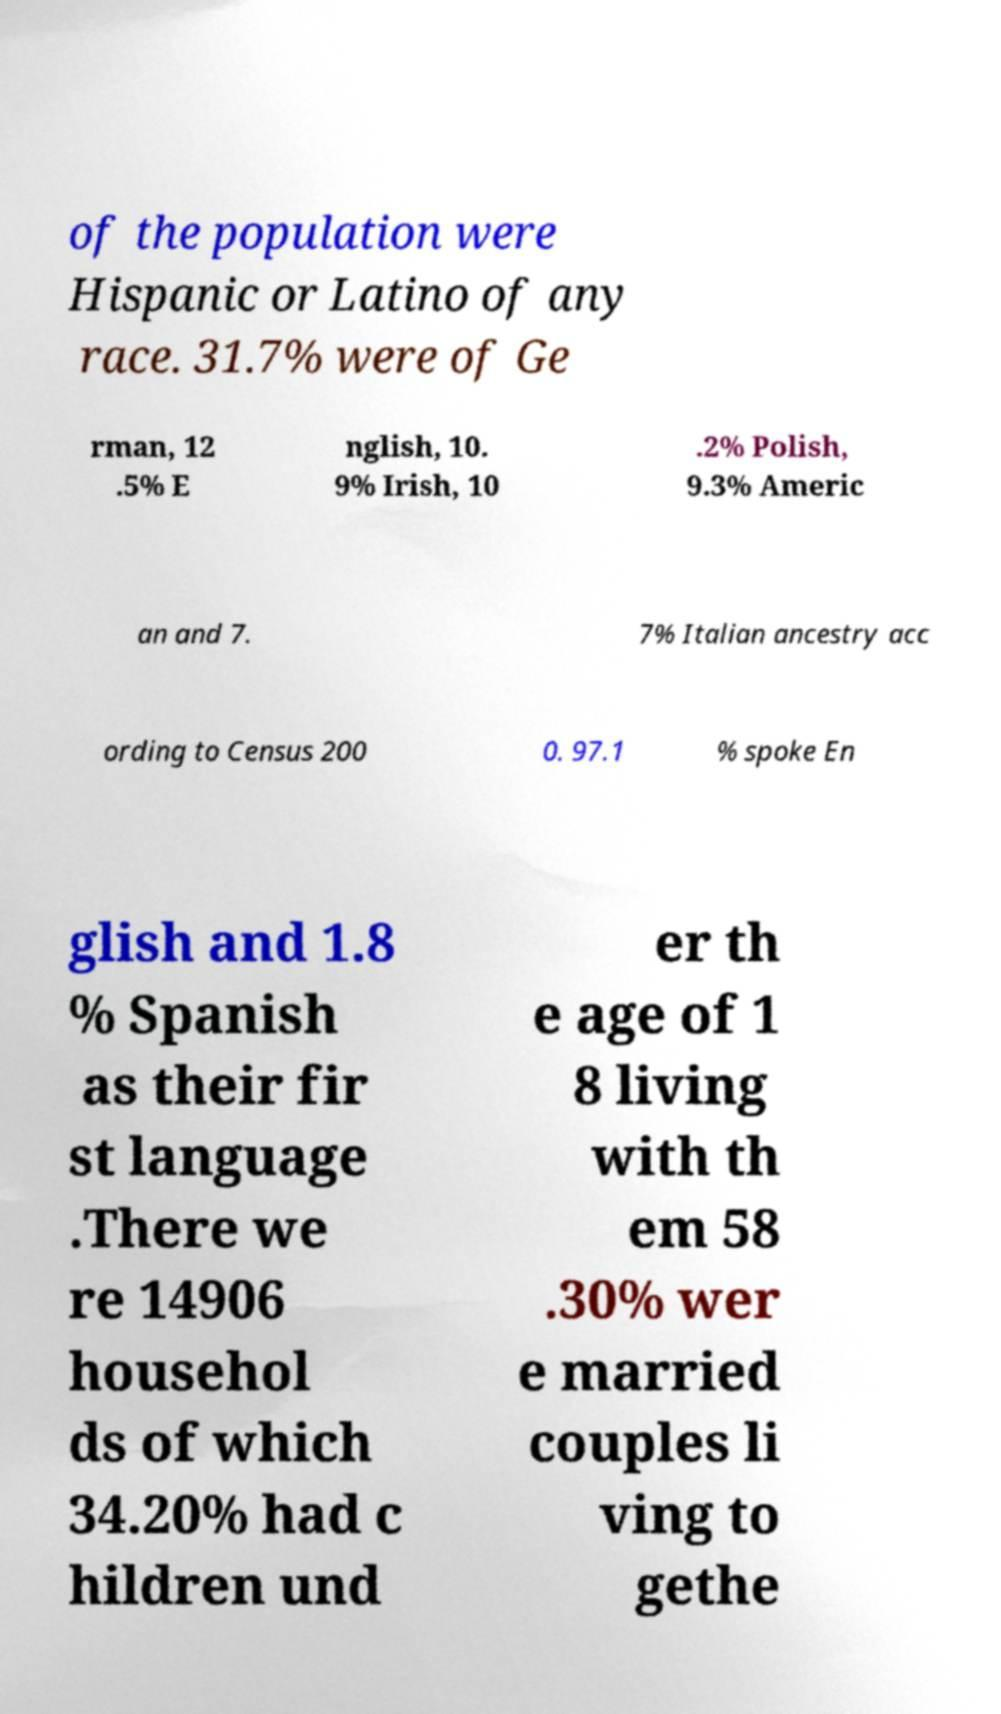Could you assist in decoding the text presented in this image and type it out clearly? of the population were Hispanic or Latino of any race. 31.7% were of Ge rman, 12 .5% E nglish, 10. 9% Irish, 10 .2% Polish, 9.3% Americ an and 7. 7% Italian ancestry acc ording to Census 200 0. 97.1 % spoke En glish and 1.8 % Spanish as their fir st language .There we re 14906 househol ds of which 34.20% had c hildren und er th e age of 1 8 living with th em 58 .30% wer e married couples li ving to gethe 